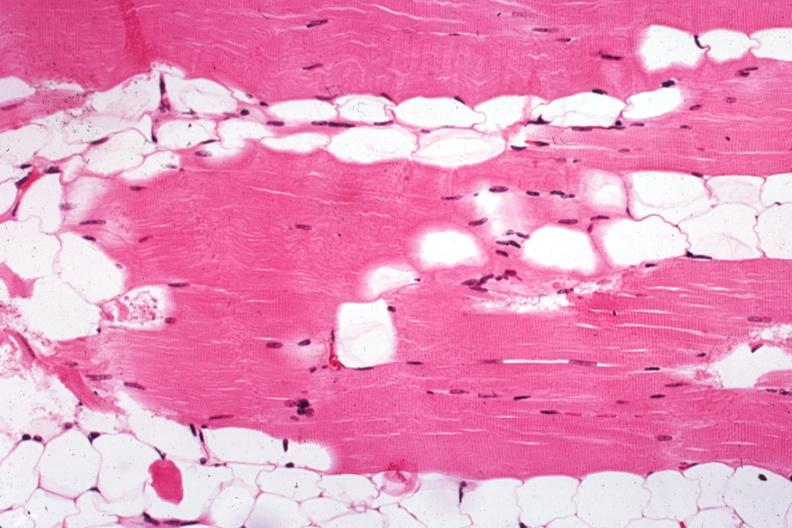s exposure present?
Answer the question using a single word or phrase. No 